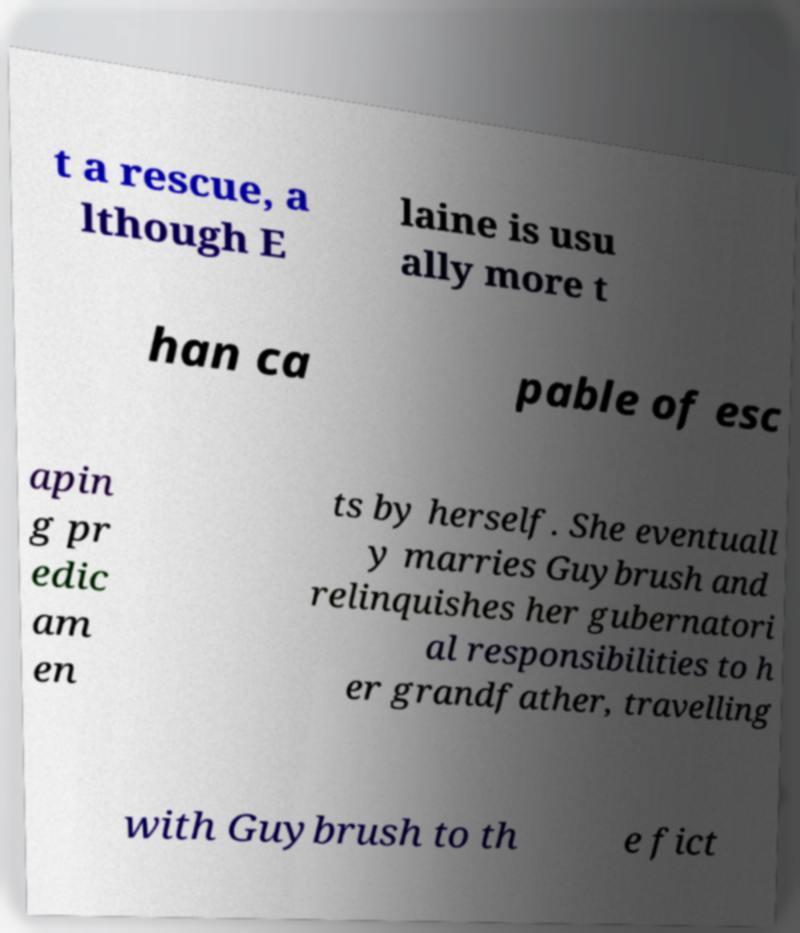Could you assist in decoding the text presented in this image and type it out clearly? t a rescue, a lthough E laine is usu ally more t han ca pable of esc apin g pr edic am en ts by herself. She eventuall y marries Guybrush and relinquishes her gubernatori al responsibilities to h er grandfather, travelling with Guybrush to th e fict 